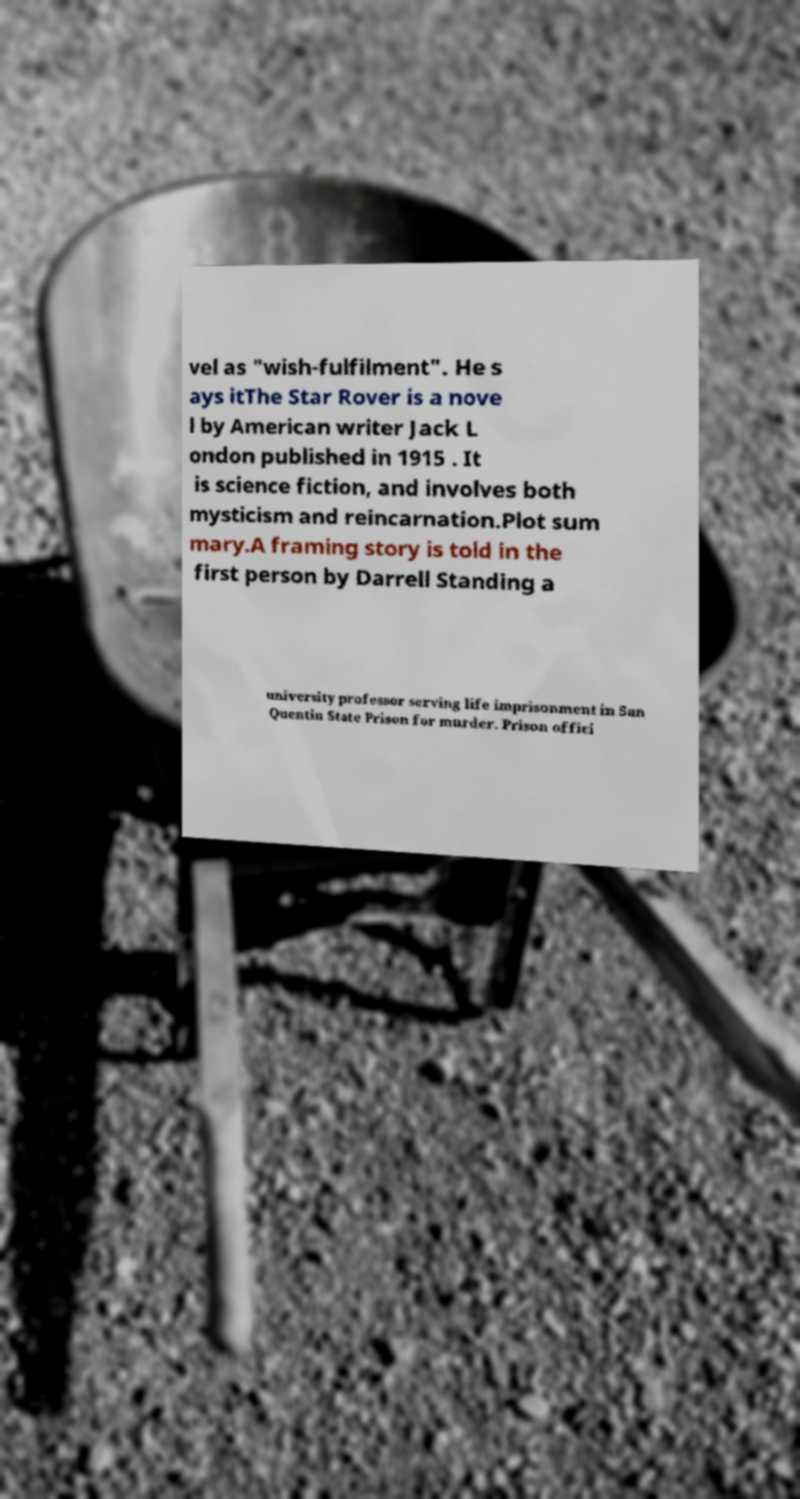Please read and relay the text visible in this image. What does it say? vel as "wish-fulfilment". He s ays itThe Star Rover is a nove l by American writer Jack L ondon published in 1915 . It is science fiction, and involves both mysticism and reincarnation.Plot sum mary.A framing story is told in the first person by Darrell Standing a university professor serving life imprisonment in San Quentin State Prison for murder. Prison offici 